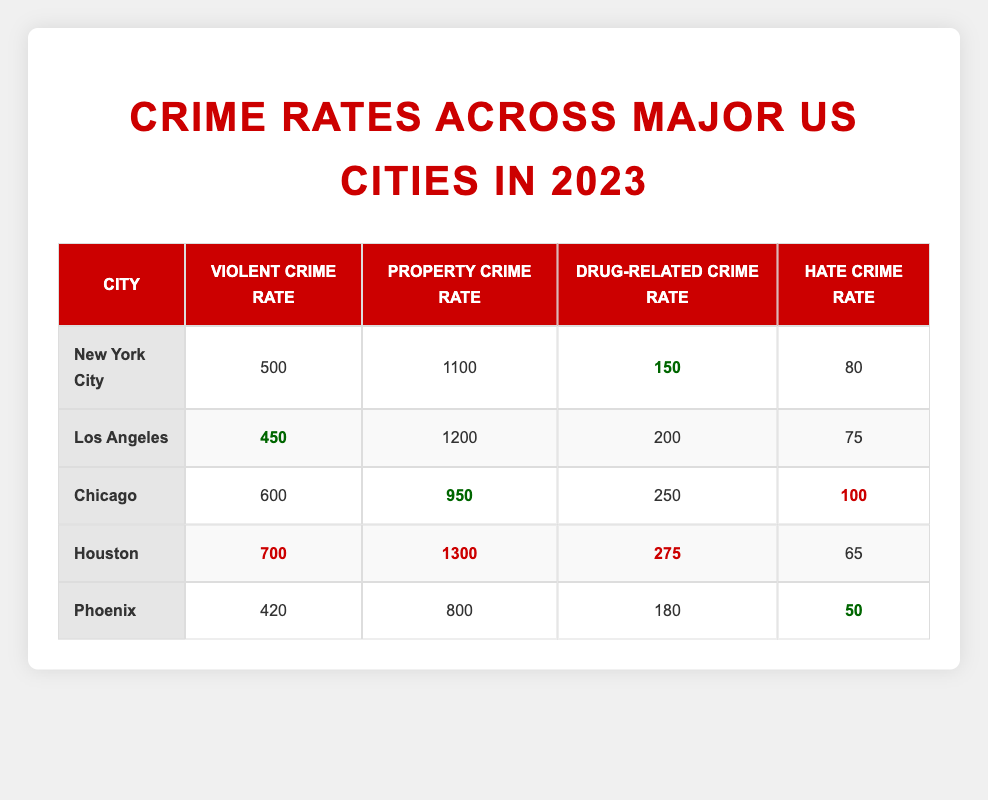What city has the highest violent crime rate in 2023? By examining the "Violent Crime Rate" column, we see the following rates: New York City (500), Los Angeles (450), Chicago (600), Houston (700), and Phoenix (420). Houston has the highest rate at 700.
Answer: Houston What is the property crime rate in Chicago? From the table under the "Property Crime Rate" column, we can see that Chicago has a property crime rate of 950.
Answer: 950 Which city has the lowest drug-related crime rate? Looking at the "Drug-Related Crime Rate" column, the values are: New York City (150), Los Angeles (200), Chicago (250), Houston (275), and Phoenix (180). New York City has the lowest at 150.
Answer: New York City Is the hate crime rate in Los Angeles higher than that in Houston? In the "Hate Crime Rate" column, Los Angeles has a rate of 75, while Houston has a rate of 65. Since 75 is greater than 65, the statement is true.
Answer: Yes What is the total of violent crime rates across all cities listed? The violent crime rates are: New York City (500), Los Angeles (450), Chicago (600), Houston (700), and Phoenix (420). We sum these values: 500 + 450 + 600 + 700 + 420 = 2670.
Answer: 2670 Which city has the highest property crime rate, and what is that rate? Examining the "Property Crime Rate" column, we find New York City (1100), Los Angeles (1200), Chicago (950), Houston (1300), and Phoenix (800). Houston has the highest at 1300.
Answer: Houston, 1300 If we took the average drug-related crime rate of all cities, what would it be? The drug-related crime rates are: New York City (150), Los Angeles (200), Chicago (250), Houston (275), and Phoenix (180). The sum is 150 + 200 + 250 + 275 + 180 = 1055, and since there are 5 cities, the average is 1055 / 5 = 211.
Answer: 211 Does Phoenix have a higher hate crime rate than Chicago? The hate crime rates are: Phoenix (50) and Chicago (100). Since 50 is less than 100, the statement is false.
Answer: No 